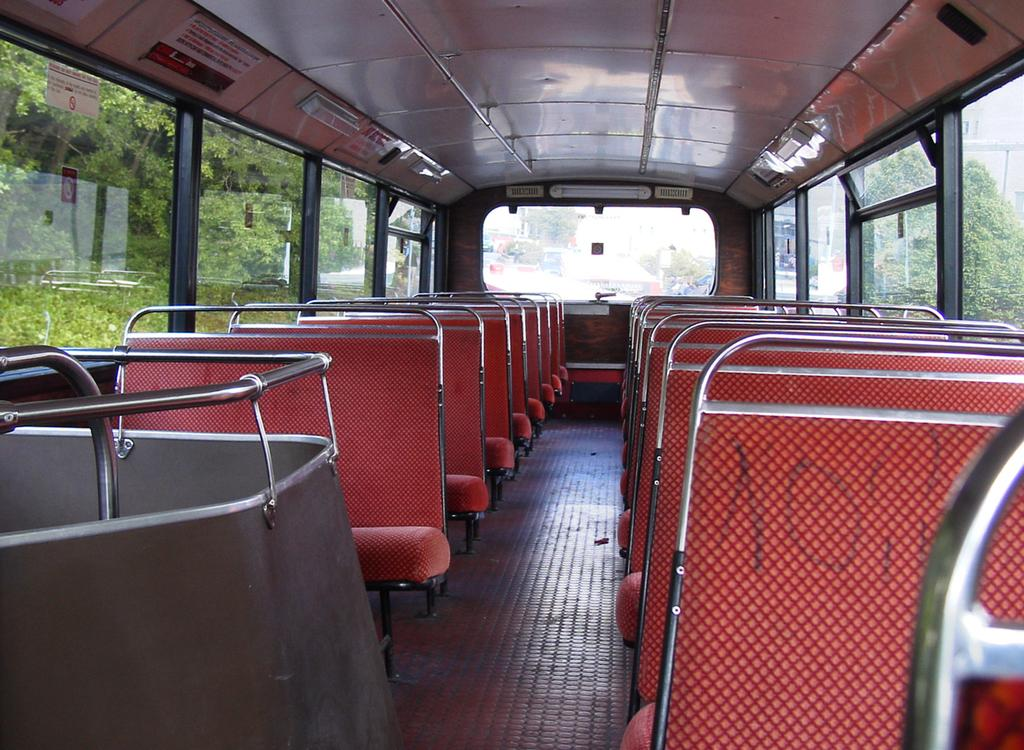Where was the image taken? The image was captured inside a bus. How many seats are occupied in the bus? There are many empty seats in the bus. What can be seen outside the bus? Trees are visible outside the bus. What is the name of the person sitting on the throne in the image? There is no throne present in the image; it was taken inside a bus with empty seats and trees visible outside. 